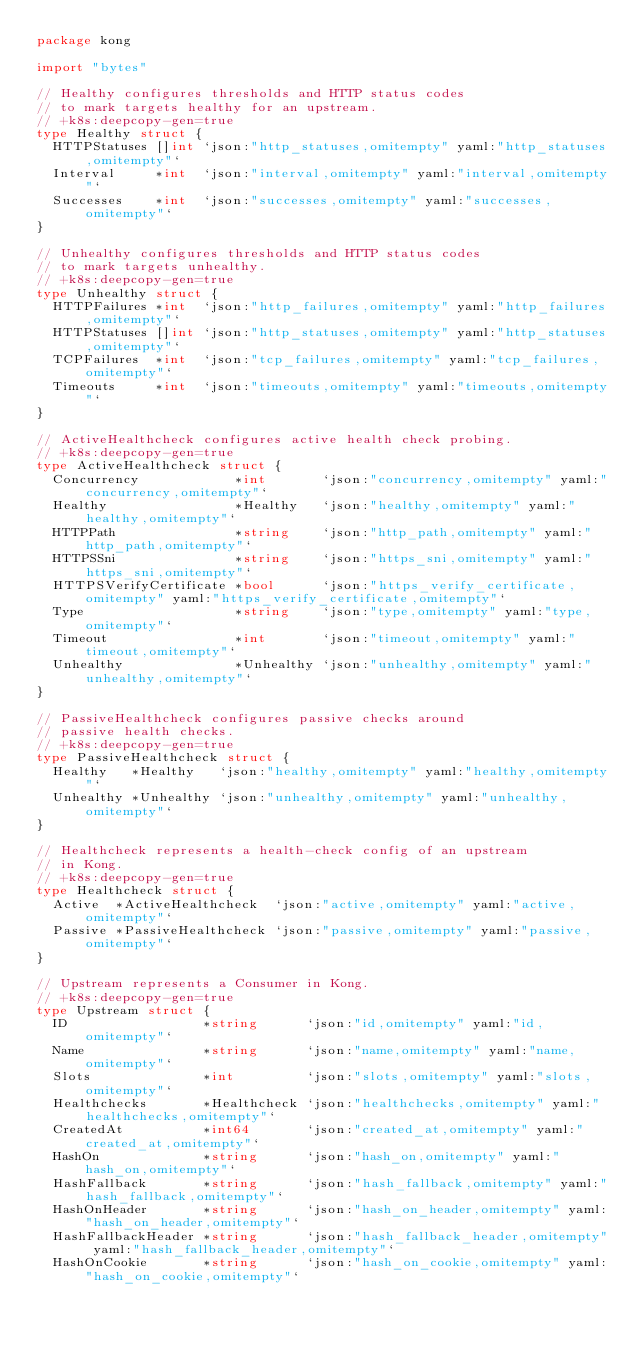Convert code to text. <code><loc_0><loc_0><loc_500><loc_500><_Go_>package kong

import "bytes"

// Healthy configures thresholds and HTTP status codes
// to mark targets healthy for an upstream.
// +k8s:deepcopy-gen=true
type Healthy struct {
	HTTPStatuses []int `json:"http_statuses,omitempty" yaml:"http_statuses,omitempty"`
	Interval     *int  `json:"interval,omitempty" yaml:"interval,omitempty"`
	Successes    *int  `json:"successes,omitempty" yaml:"successes,omitempty"`
}

// Unhealthy configures thresholds and HTTP status codes
// to mark targets unhealthy.
// +k8s:deepcopy-gen=true
type Unhealthy struct {
	HTTPFailures *int  `json:"http_failures,omitempty" yaml:"http_failures,omitempty"`
	HTTPStatuses []int `json:"http_statuses,omitempty" yaml:"http_statuses,omitempty"`
	TCPFailures  *int  `json:"tcp_failures,omitempty" yaml:"tcp_failures,omitempty"`
	Timeouts     *int  `json:"timeouts,omitempty" yaml:"timeouts,omitempty"`
}

// ActiveHealthcheck configures active health check probing.
// +k8s:deepcopy-gen=true
type ActiveHealthcheck struct {
	Concurrency            *int       `json:"concurrency,omitempty" yaml:"concurrency,omitempty"`
	Healthy                *Healthy   `json:"healthy,omitempty" yaml:"healthy,omitempty"`
	HTTPPath               *string    `json:"http_path,omitempty" yaml:"http_path,omitempty"`
	HTTPSSni               *string    `json:"https_sni,omitempty" yaml:"https_sni,omitempty"`
	HTTPSVerifyCertificate *bool      `json:"https_verify_certificate,omitempty" yaml:"https_verify_certificate,omitempty"`
	Type                   *string    `json:"type,omitempty" yaml:"type,omitempty"`
	Timeout                *int       `json:"timeout,omitempty" yaml:"timeout,omitempty"`
	Unhealthy              *Unhealthy `json:"unhealthy,omitempty" yaml:"unhealthy,omitempty"`
}

// PassiveHealthcheck configures passive checks around
// passive health checks.
// +k8s:deepcopy-gen=true
type PassiveHealthcheck struct {
	Healthy   *Healthy   `json:"healthy,omitempty" yaml:"healthy,omitempty"`
	Unhealthy *Unhealthy `json:"unhealthy,omitempty" yaml:"unhealthy,omitempty"`
}

// Healthcheck represents a health-check config of an upstream
// in Kong.
// +k8s:deepcopy-gen=true
type Healthcheck struct {
	Active  *ActiveHealthcheck  `json:"active,omitempty" yaml:"active,omitempty"`
	Passive *PassiveHealthcheck `json:"passive,omitempty" yaml:"passive,omitempty"`
}

// Upstream represents a Consumer in Kong.
// +k8s:deepcopy-gen=true
type Upstream struct {
	ID                 *string      `json:"id,omitempty" yaml:"id,omitempty"`
	Name               *string      `json:"name,omitempty" yaml:"name,omitempty"`
	Slots              *int         `json:"slots,omitempty" yaml:"slots,omitempty"`
	Healthchecks       *Healthcheck `json:"healthchecks,omitempty" yaml:"healthchecks,omitempty"`
	CreatedAt          *int64       `json:"created_at,omitempty" yaml:"created_at,omitempty"`
	HashOn             *string      `json:"hash_on,omitempty" yaml:"hash_on,omitempty"`
	HashFallback       *string      `json:"hash_fallback,omitempty" yaml:"hash_fallback,omitempty"`
	HashOnHeader       *string      `json:"hash_on_header,omitempty" yaml:"hash_on_header,omitempty"`
	HashFallbackHeader *string      `json:"hash_fallback_header,omitempty" yaml:"hash_fallback_header,omitempty"`
	HashOnCookie       *string      `json:"hash_on_cookie,omitempty" yaml:"hash_on_cookie,omitempty"`</code> 